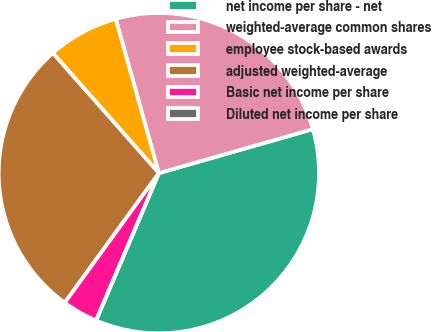Convert chart to OTSL. <chart><loc_0><loc_0><loc_500><loc_500><pie_chart><fcel>net income per share - net<fcel>weighted-average common shares<fcel>employee stock-based awards<fcel>adjusted weighted-average<fcel>Basic net income per share<fcel>Diluted net income per share<nl><fcel>35.84%<fcel>24.91%<fcel>7.17%<fcel>28.49%<fcel>3.58%<fcel>0.0%<nl></chart> 